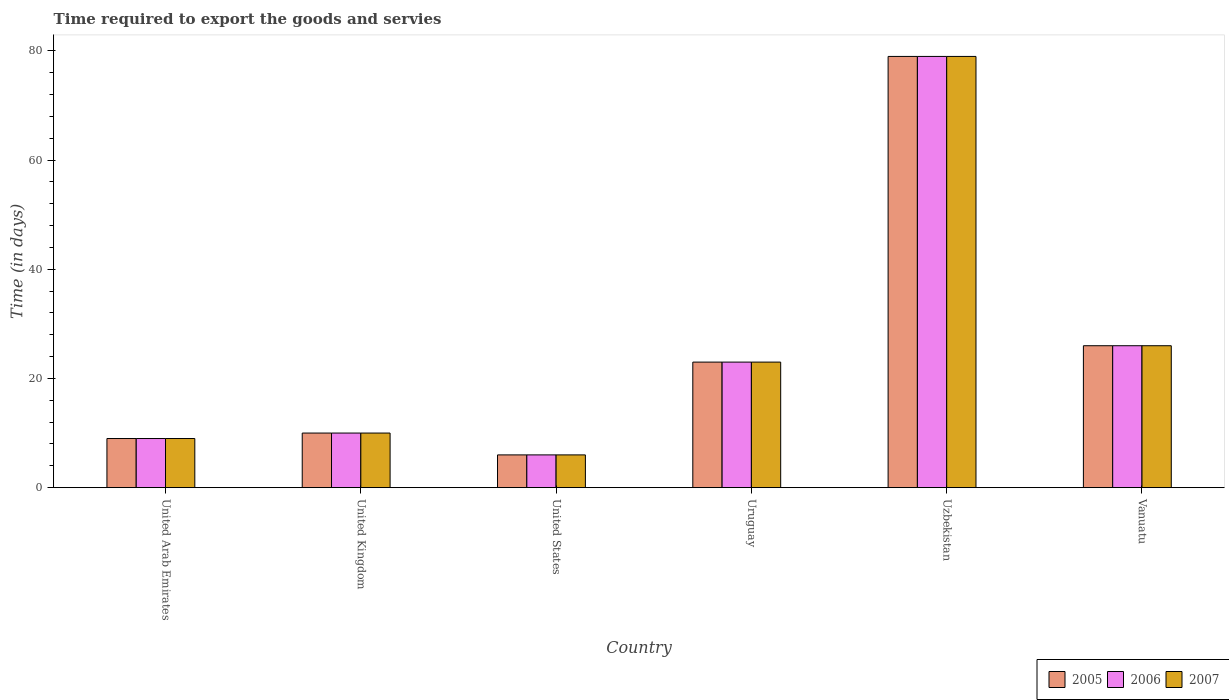How many different coloured bars are there?
Your answer should be compact. 3. Are the number of bars per tick equal to the number of legend labels?
Provide a succinct answer. Yes. Are the number of bars on each tick of the X-axis equal?
Your answer should be compact. Yes. How many bars are there on the 1st tick from the left?
Your answer should be compact. 3. How many bars are there on the 3rd tick from the right?
Ensure brevity in your answer.  3. What is the label of the 4th group of bars from the left?
Your answer should be very brief. Uruguay. What is the number of days required to export the goods and services in 2006 in United States?
Give a very brief answer. 6. Across all countries, what is the maximum number of days required to export the goods and services in 2007?
Your response must be concise. 79. Across all countries, what is the minimum number of days required to export the goods and services in 2005?
Your response must be concise. 6. In which country was the number of days required to export the goods and services in 2006 maximum?
Provide a succinct answer. Uzbekistan. What is the total number of days required to export the goods and services in 2007 in the graph?
Keep it short and to the point. 153. What is the difference between the number of days required to export the goods and services in 2005 in United Kingdom and that in Vanuatu?
Your answer should be compact. -16. What is the average number of days required to export the goods and services in 2005 per country?
Ensure brevity in your answer.  25.5. Is the difference between the number of days required to export the goods and services in 2006 in United Arab Emirates and United Kingdom greater than the difference between the number of days required to export the goods and services in 2005 in United Arab Emirates and United Kingdom?
Give a very brief answer. No. What is the difference between the highest and the lowest number of days required to export the goods and services in 2006?
Make the answer very short. 73. In how many countries, is the number of days required to export the goods and services in 2007 greater than the average number of days required to export the goods and services in 2007 taken over all countries?
Offer a terse response. 2. Is the sum of the number of days required to export the goods and services in 2006 in United Kingdom and United States greater than the maximum number of days required to export the goods and services in 2007 across all countries?
Provide a short and direct response. No. What does the 2nd bar from the right in Uzbekistan represents?
Keep it short and to the point. 2006. Is it the case that in every country, the sum of the number of days required to export the goods and services in 2007 and number of days required to export the goods and services in 2005 is greater than the number of days required to export the goods and services in 2006?
Offer a terse response. Yes. How many bars are there?
Your answer should be compact. 18. What is the difference between two consecutive major ticks on the Y-axis?
Make the answer very short. 20. Are the values on the major ticks of Y-axis written in scientific E-notation?
Your answer should be very brief. No. Does the graph contain grids?
Your response must be concise. No. What is the title of the graph?
Keep it short and to the point. Time required to export the goods and servies. What is the label or title of the X-axis?
Offer a very short reply. Country. What is the label or title of the Y-axis?
Make the answer very short. Time (in days). What is the Time (in days) of 2006 in United Arab Emirates?
Offer a terse response. 9. What is the Time (in days) of 2007 in United Arab Emirates?
Your answer should be compact. 9. What is the Time (in days) of 2005 in United Kingdom?
Your response must be concise. 10. What is the Time (in days) in 2007 in United Kingdom?
Provide a succinct answer. 10. What is the Time (in days) of 2005 in United States?
Your response must be concise. 6. What is the Time (in days) of 2005 in Uruguay?
Provide a short and direct response. 23. What is the Time (in days) in 2007 in Uruguay?
Make the answer very short. 23. What is the Time (in days) of 2005 in Uzbekistan?
Make the answer very short. 79. What is the Time (in days) in 2006 in Uzbekistan?
Ensure brevity in your answer.  79. What is the Time (in days) in 2007 in Uzbekistan?
Ensure brevity in your answer.  79. What is the Time (in days) of 2006 in Vanuatu?
Your response must be concise. 26. What is the Time (in days) in 2007 in Vanuatu?
Ensure brevity in your answer.  26. Across all countries, what is the maximum Time (in days) of 2005?
Offer a very short reply. 79. Across all countries, what is the maximum Time (in days) of 2006?
Give a very brief answer. 79. Across all countries, what is the maximum Time (in days) of 2007?
Your answer should be very brief. 79. Across all countries, what is the minimum Time (in days) of 2005?
Keep it short and to the point. 6. Across all countries, what is the minimum Time (in days) in 2006?
Your answer should be compact. 6. What is the total Time (in days) in 2005 in the graph?
Your answer should be compact. 153. What is the total Time (in days) of 2006 in the graph?
Ensure brevity in your answer.  153. What is the total Time (in days) of 2007 in the graph?
Offer a very short reply. 153. What is the difference between the Time (in days) of 2005 in United Arab Emirates and that in United Kingdom?
Offer a terse response. -1. What is the difference between the Time (in days) in 2006 in United Arab Emirates and that in United Kingdom?
Your response must be concise. -1. What is the difference between the Time (in days) of 2005 in United Arab Emirates and that in United States?
Your answer should be compact. 3. What is the difference between the Time (in days) of 2007 in United Arab Emirates and that in United States?
Provide a succinct answer. 3. What is the difference between the Time (in days) of 2005 in United Arab Emirates and that in Uruguay?
Your answer should be very brief. -14. What is the difference between the Time (in days) of 2006 in United Arab Emirates and that in Uruguay?
Keep it short and to the point. -14. What is the difference between the Time (in days) in 2007 in United Arab Emirates and that in Uruguay?
Offer a terse response. -14. What is the difference between the Time (in days) of 2005 in United Arab Emirates and that in Uzbekistan?
Ensure brevity in your answer.  -70. What is the difference between the Time (in days) in 2006 in United Arab Emirates and that in Uzbekistan?
Offer a terse response. -70. What is the difference between the Time (in days) in 2007 in United Arab Emirates and that in Uzbekistan?
Your answer should be compact. -70. What is the difference between the Time (in days) in 2006 in United Arab Emirates and that in Vanuatu?
Make the answer very short. -17. What is the difference between the Time (in days) in 2007 in United Arab Emirates and that in Vanuatu?
Provide a succinct answer. -17. What is the difference between the Time (in days) of 2005 in United Kingdom and that in United States?
Give a very brief answer. 4. What is the difference between the Time (in days) of 2006 in United Kingdom and that in United States?
Keep it short and to the point. 4. What is the difference between the Time (in days) in 2006 in United Kingdom and that in Uruguay?
Give a very brief answer. -13. What is the difference between the Time (in days) of 2005 in United Kingdom and that in Uzbekistan?
Your response must be concise. -69. What is the difference between the Time (in days) of 2006 in United Kingdom and that in Uzbekistan?
Give a very brief answer. -69. What is the difference between the Time (in days) in 2007 in United Kingdom and that in Uzbekistan?
Offer a very short reply. -69. What is the difference between the Time (in days) in 2006 in United Kingdom and that in Vanuatu?
Make the answer very short. -16. What is the difference between the Time (in days) of 2005 in United States and that in Uzbekistan?
Make the answer very short. -73. What is the difference between the Time (in days) of 2006 in United States and that in Uzbekistan?
Your answer should be very brief. -73. What is the difference between the Time (in days) of 2007 in United States and that in Uzbekistan?
Provide a short and direct response. -73. What is the difference between the Time (in days) of 2007 in United States and that in Vanuatu?
Offer a very short reply. -20. What is the difference between the Time (in days) in 2005 in Uruguay and that in Uzbekistan?
Provide a short and direct response. -56. What is the difference between the Time (in days) of 2006 in Uruguay and that in Uzbekistan?
Provide a short and direct response. -56. What is the difference between the Time (in days) in 2007 in Uruguay and that in Uzbekistan?
Your response must be concise. -56. What is the difference between the Time (in days) of 2005 in Uruguay and that in Vanuatu?
Offer a terse response. -3. What is the difference between the Time (in days) of 2007 in Uruguay and that in Vanuatu?
Make the answer very short. -3. What is the difference between the Time (in days) in 2006 in Uzbekistan and that in Vanuatu?
Your response must be concise. 53. What is the difference between the Time (in days) in 2005 in United Arab Emirates and the Time (in days) in 2007 in United Kingdom?
Keep it short and to the point. -1. What is the difference between the Time (in days) in 2005 in United Arab Emirates and the Time (in days) in 2006 in Uruguay?
Provide a succinct answer. -14. What is the difference between the Time (in days) in 2006 in United Arab Emirates and the Time (in days) in 2007 in Uruguay?
Your answer should be very brief. -14. What is the difference between the Time (in days) of 2005 in United Arab Emirates and the Time (in days) of 2006 in Uzbekistan?
Ensure brevity in your answer.  -70. What is the difference between the Time (in days) in 2005 in United Arab Emirates and the Time (in days) in 2007 in Uzbekistan?
Provide a succinct answer. -70. What is the difference between the Time (in days) in 2006 in United Arab Emirates and the Time (in days) in 2007 in Uzbekistan?
Provide a succinct answer. -70. What is the difference between the Time (in days) of 2006 in United Arab Emirates and the Time (in days) of 2007 in Vanuatu?
Your answer should be compact. -17. What is the difference between the Time (in days) in 2006 in United Kingdom and the Time (in days) in 2007 in United States?
Keep it short and to the point. 4. What is the difference between the Time (in days) in 2005 in United Kingdom and the Time (in days) in 2006 in Uzbekistan?
Your answer should be compact. -69. What is the difference between the Time (in days) in 2005 in United Kingdom and the Time (in days) in 2007 in Uzbekistan?
Ensure brevity in your answer.  -69. What is the difference between the Time (in days) in 2006 in United Kingdom and the Time (in days) in 2007 in Uzbekistan?
Give a very brief answer. -69. What is the difference between the Time (in days) of 2005 in United Kingdom and the Time (in days) of 2006 in Vanuatu?
Offer a very short reply. -16. What is the difference between the Time (in days) of 2005 in United Kingdom and the Time (in days) of 2007 in Vanuatu?
Offer a terse response. -16. What is the difference between the Time (in days) of 2005 in United States and the Time (in days) of 2006 in Uruguay?
Ensure brevity in your answer.  -17. What is the difference between the Time (in days) in 2006 in United States and the Time (in days) in 2007 in Uruguay?
Offer a very short reply. -17. What is the difference between the Time (in days) in 2005 in United States and the Time (in days) in 2006 in Uzbekistan?
Keep it short and to the point. -73. What is the difference between the Time (in days) of 2005 in United States and the Time (in days) of 2007 in Uzbekistan?
Give a very brief answer. -73. What is the difference between the Time (in days) in 2006 in United States and the Time (in days) in 2007 in Uzbekistan?
Your answer should be compact. -73. What is the difference between the Time (in days) of 2005 in United States and the Time (in days) of 2006 in Vanuatu?
Your answer should be compact. -20. What is the difference between the Time (in days) of 2005 in Uruguay and the Time (in days) of 2006 in Uzbekistan?
Your answer should be very brief. -56. What is the difference between the Time (in days) in 2005 in Uruguay and the Time (in days) in 2007 in Uzbekistan?
Provide a succinct answer. -56. What is the difference between the Time (in days) of 2006 in Uruguay and the Time (in days) of 2007 in Uzbekistan?
Keep it short and to the point. -56. What is the difference between the Time (in days) of 2005 in Uruguay and the Time (in days) of 2007 in Vanuatu?
Provide a short and direct response. -3. What is the difference between the Time (in days) in 2006 in Uruguay and the Time (in days) in 2007 in Vanuatu?
Give a very brief answer. -3. What is the average Time (in days) of 2007 per country?
Keep it short and to the point. 25.5. What is the difference between the Time (in days) in 2005 and Time (in days) in 2006 in United Arab Emirates?
Your answer should be very brief. 0. What is the difference between the Time (in days) in 2005 and Time (in days) in 2006 in United Kingdom?
Your answer should be compact. 0. What is the difference between the Time (in days) of 2006 and Time (in days) of 2007 in United States?
Provide a succinct answer. 0. What is the difference between the Time (in days) of 2005 and Time (in days) of 2006 in Uruguay?
Keep it short and to the point. 0. What is the difference between the Time (in days) of 2006 and Time (in days) of 2007 in Uruguay?
Your answer should be compact. 0. What is the difference between the Time (in days) of 2005 and Time (in days) of 2006 in Uzbekistan?
Ensure brevity in your answer.  0. What is the difference between the Time (in days) in 2006 and Time (in days) in 2007 in Uzbekistan?
Your answer should be compact. 0. What is the difference between the Time (in days) of 2005 and Time (in days) of 2007 in Vanuatu?
Your answer should be compact. 0. What is the ratio of the Time (in days) in 2005 in United Arab Emirates to that in United Kingdom?
Offer a very short reply. 0.9. What is the ratio of the Time (in days) of 2006 in United Arab Emirates to that in United Kingdom?
Your answer should be very brief. 0.9. What is the ratio of the Time (in days) of 2007 in United Arab Emirates to that in United States?
Give a very brief answer. 1.5. What is the ratio of the Time (in days) of 2005 in United Arab Emirates to that in Uruguay?
Your answer should be compact. 0.39. What is the ratio of the Time (in days) in 2006 in United Arab Emirates to that in Uruguay?
Provide a succinct answer. 0.39. What is the ratio of the Time (in days) in 2007 in United Arab Emirates to that in Uruguay?
Your response must be concise. 0.39. What is the ratio of the Time (in days) of 2005 in United Arab Emirates to that in Uzbekistan?
Your answer should be compact. 0.11. What is the ratio of the Time (in days) of 2006 in United Arab Emirates to that in Uzbekistan?
Keep it short and to the point. 0.11. What is the ratio of the Time (in days) of 2007 in United Arab Emirates to that in Uzbekistan?
Keep it short and to the point. 0.11. What is the ratio of the Time (in days) of 2005 in United Arab Emirates to that in Vanuatu?
Your response must be concise. 0.35. What is the ratio of the Time (in days) in 2006 in United Arab Emirates to that in Vanuatu?
Provide a short and direct response. 0.35. What is the ratio of the Time (in days) of 2007 in United Arab Emirates to that in Vanuatu?
Offer a very short reply. 0.35. What is the ratio of the Time (in days) in 2007 in United Kingdom to that in United States?
Your response must be concise. 1.67. What is the ratio of the Time (in days) in 2005 in United Kingdom to that in Uruguay?
Ensure brevity in your answer.  0.43. What is the ratio of the Time (in days) of 2006 in United Kingdom to that in Uruguay?
Ensure brevity in your answer.  0.43. What is the ratio of the Time (in days) of 2007 in United Kingdom to that in Uruguay?
Keep it short and to the point. 0.43. What is the ratio of the Time (in days) in 2005 in United Kingdom to that in Uzbekistan?
Your response must be concise. 0.13. What is the ratio of the Time (in days) of 2006 in United Kingdom to that in Uzbekistan?
Keep it short and to the point. 0.13. What is the ratio of the Time (in days) of 2007 in United Kingdom to that in Uzbekistan?
Make the answer very short. 0.13. What is the ratio of the Time (in days) of 2005 in United Kingdom to that in Vanuatu?
Your response must be concise. 0.38. What is the ratio of the Time (in days) in 2006 in United Kingdom to that in Vanuatu?
Provide a succinct answer. 0.38. What is the ratio of the Time (in days) in 2007 in United Kingdom to that in Vanuatu?
Your response must be concise. 0.38. What is the ratio of the Time (in days) in 2005 in United States to that in Uruguay?
Give a very brief answer. 0.26. What is the ratio of the Time (in days) of 2006 in United States to that in Uruguay?
Offer a very short reply. 0.26. What is the ratio of the Time (in days) of 2007 in United States to that in Uruguay?
Provide a short and direct response. 0.26. What is the ratio of the Time (in days) of 2005 in United States to that in Uzbekistan?
Keep it short and to the point. 0.08. What is the ratio of the Time (in days) in 2006 in United States to that in Uzbekistan?
Provide a short and direct response. 0.08. What is the ratio of the Time (in days) in 2007 in United States to that in Uzbekistan?
Make the answer very short. 0.08. What is the ratio of the Time (in days) of 2005 in United States to that in Vanuatu?
Your response must be concise. 0.23. What is the ratio of the Time (in days) of 2006 in United States to that in Vanuatu?
Ensure brevity in your answer.  0.23. What is the ratio of the Time (in days) in 2007 in United States to that in Vanuatu?
Ensure brevity in your answer.  0.23. What is the ratio of the Time (in days) in 2005 in Uruguay to that in Uzbekistan?
Your answer should be compact. 0.29. What is the ratio of the Time (in days) of 2006 in Uruguay to that in Uzbekistan?
Give a very brief answer. 0.29. What is the ratio of the Time (in days) in 2007 in Uruguay to that in Uzbekistan?
Give a very brief answer. 0.29. What is the ratio of the Time (in days) in 2005 in Uruguay to that in Vanuatu?
Provide a succinct answer. 0.88. What is the ratio of the Time (in days) of 2006 in Uruguay to that in Vanuatu?
Offer a terse response. 0.88. What is the ratio of the Time (in days) of 2007 in Uruguay to that in Vanuatu?
Provide a succinct answer. 0.88. What is the ratio of the Time (in days) of 2005 in Uzbekistan to that in Vanuatu?
Provide a short and direct response. 3.04. What is the ratio of the Time (in days) in 2006 in Uzbekistan to that in Vanuatu?
Your response must be concise. 3.04. What is the ratio of the Time (in days) in 2007 in Uzbekistan to that in Vanuatu?
Offer a very short reply. 3.04. What is the difference between the highest and the second highest Time (in days) of 2006?
Provide a succinct answer. 53. What is the difference between the highest and the second highest Time (in days) of 2007?
Ensure brevity in your answer.  53. What is the difference between the highest and the lowest Time (in days) in 2005?
Ensure brevity in your answer.  73. What is the difference between the highest and the lowest Time (in days) of 2006?
Ensure brevity in your answer.  73. What is the difference between the highest and the lowest Time (in days) of 2007?
Provide a short and direct response. 73. 